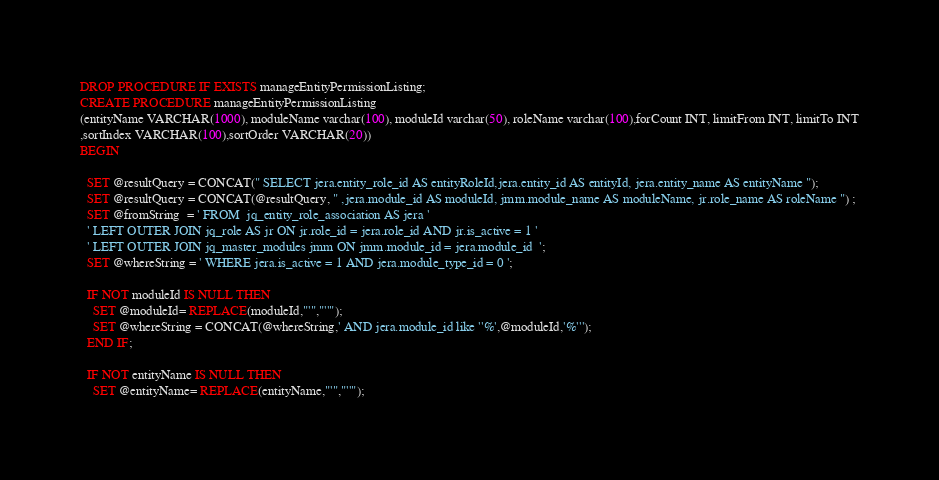<code> <loc_0><loc_0><loc_500><loc_500><_SQL_>DROP PROCEDURE IF EXISTS manageEntityPermissionListing;
CREATE PROCEDURE manageEntityPermissionListing
(entityName VARCHAR(1000), moduleName varchar(100), moduleId varchar(50), roleName varchar(100),forCount INT, limitFrom INT, limitTo INT
,sortIndex VARCHAR(100),sortOrder VARCHAR(20))
BEGIN

  SET @resultQuery = CONCAT(" SELECT jera.entity_role_id AS entityRoleId,jera.entity_id AS entityId, jera.entity_name AS entityName ");
  SET @resultQuery = CONCAT(@resultQuery, " ,jera.module_id AS moduleId, jmm.module_name AS moduleName, jr.role_name AS roleName ") ;
  SET @fromString  = ' FROM  jq_entity_role_association AS jera '
  ' LEFT OUTER JOIN jq_role AS jr ON jr.role_id = jera.role_id AND jr.is_active = 1 '
  ' LEFT OUTER JOIN jq_master_modules jmm ON jmm.module_id = jera.module_id  ';
  SET @whereString = ' WHERE jera.is_active = 1 AND jera.module_type_id = 0 ';
   
  IF NOT moduleId IS NULL THEN
    SET @moduleId= REPLACE(moduleId,"'","''");
    SET @whereString = CONCAT(@whereString,' AND jera.module_id like ''%',@moduleId,'%''');
  END IF;
  
  IF NOT entityName IS NULL THEN
    SET @entityName= REPLACE(entityName,"'","''");</code> 